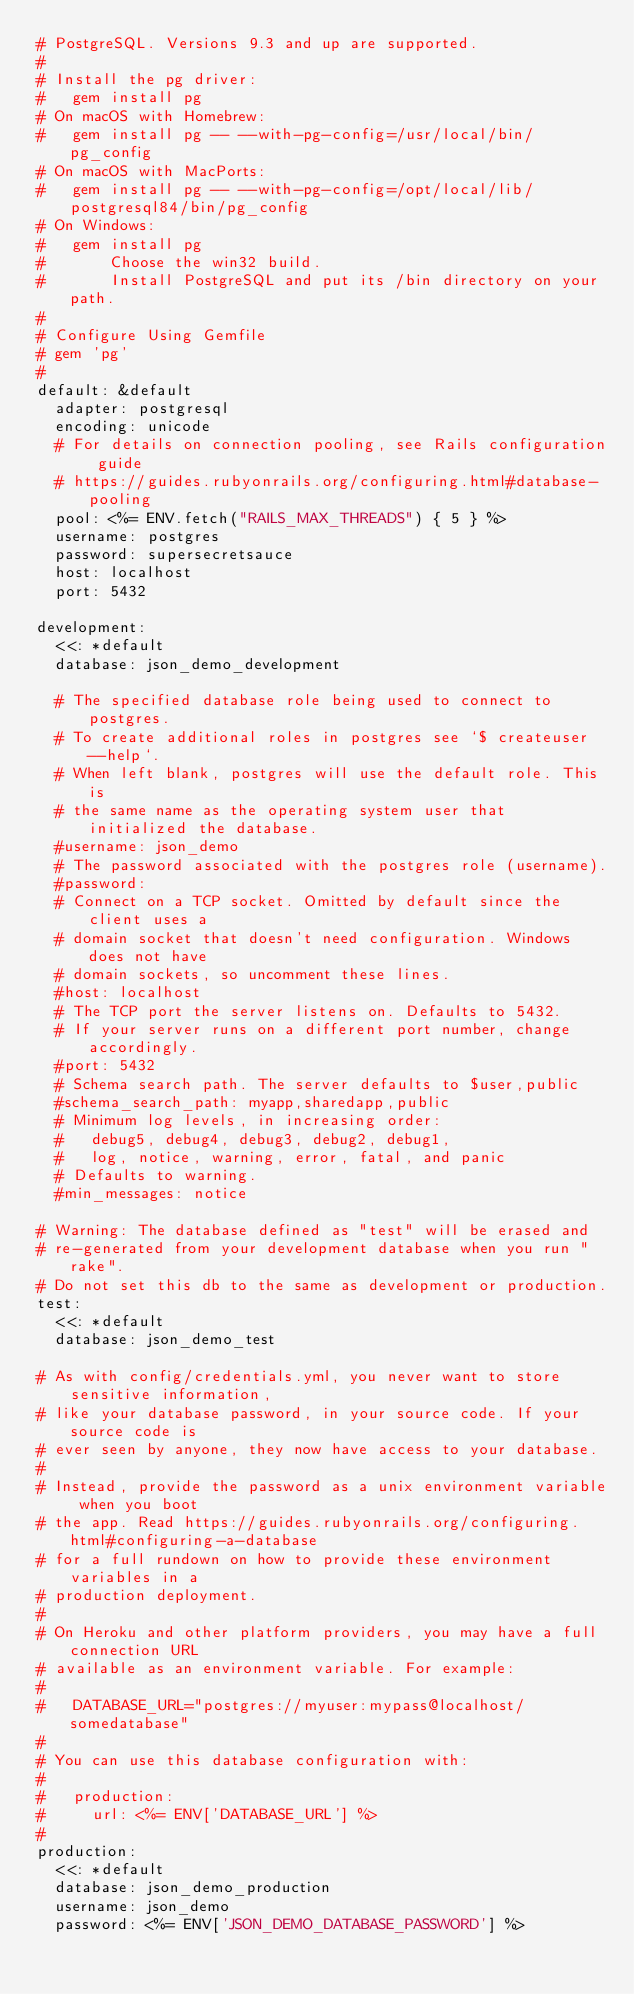Convert code to text. <code><loc_0><loc_0><loc_500><loc_500><_YAML_># PostgreSQL. Versions 9.3 and up are supported.
#
# Install the pg driver:
#   gem install pg
# On macOS with Homebrew:
#   gem install pg -- --with-pg-config=/usr/local/bin/pg_config
# On macOS with MacPorts:
#   gem install pg -- --with-pg-config=/opt/local/lib/postgresql84/bin/pg_config
# On Windows:
#   gem install pg
#       Choose the win32 build.
#       Install PostgreSQL and put its /bin directory on your path.
#
# Configure Using Gemfile
# gem 'pg'
#
default: &default
  adapter: postgresql
  encoding: unicode
  # For details on connection pooling, see Rails configuration guide
  # https://guides.rubyonrails.org/configuring.html#database-pooling
  pool: <%= ENV.fetch("RAILS_MAX_THREADS") { 5 } %>
  username: postgres
  password: supersecretsauce
  host: localhost
  port: 5432

development:
  <<: *default
  database: json_demo_development

  # The specified database role being used to connect to postgres.
  # To create additional roles in postgres see `$ createuser --help`.
  # When left blank, postgres will use the default role. This is
  # the same name as the operating system user that initialized the database.
  #username: json_demo
  # The password associated with the postgres role (username).
  #password:
  # Connect on a TCP socket. Omitted by default since the client uses a
  # domain socket that doesn't need configuration. Windows does not have
  # domain sockets, so uncomment these lines.
  #host: localhost
  # The TCP port the server listens on. Defaults to 5432.
  # If your server runs on a different port number, change accordingly.
  #port: 5432
  # Schema search path. The server defaults to $user,public
  #schema_search_path: myapp,sharedapp,public
  # Minimum log levels, in increasing order:
  #   debug5, debug4, debug3, debug2, debug1,
  #   log, notice, warning, error, fatal, and panic
  # Defaults to warning.
  #min_messages: notice

# Warning: The database defined as "test" will be erased and
# re-generated from your development database when you run "rake".
# Do not set this db to the same as development or production.
test:
  <<: *default
  database: json_demo_test

# As with config/credentials.yml, you never want to store sensitive information,
# like your database password, in your source code. If your source code is
# ever seen by anyone, they now have access to your database.
#
# Instead, provide the password as a unix environment variable when you boot
# the app. Read https://guides.rubyonrails.org/configuring.html#configuring-a-database
# for a full rundown on how to provide these environment variables in a
# production deployment.
#
# On Heroku and other platform providers, you may have a full connection URL
# available as an environment variable. For example:
#
#   DATABASE_URL="postgres://myuser:mypass@localhost/somedatabase"
#
# You can use this database configuration with:
#
#   production:
#     url: <%= ENV['DATABASE_URL'] %>
#
production:
  <<: *default
  database: json_demo_production
  username: json_demo
  password: <%= ENV['JSON_DEMO_DATABASE_PASSWORD'] %>
</code> 